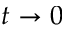Convert formula to latex. <formula><loc_0><loc_0><loc_500><loc_500>t \rightarrow 0</formula> 